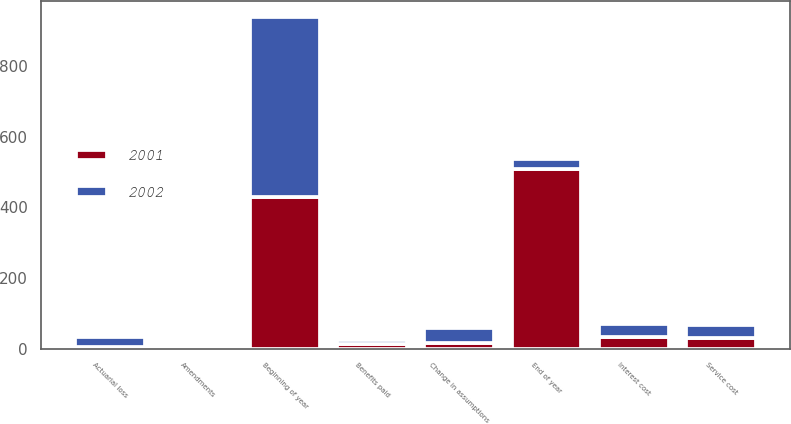Convert chart. <chart><loc_0><loc_0><loc_500><loc_500><stacked_bar_chart><ecel><fcel>Beginning of year<fcel>Service cost<fcel>Interest cost<fcel>Amendments<fcel>Change in assumptions<fcel>Actuarial loss<fcel>Benefits paid<fcel>End of year<nl><fcel>2001<fcel>430.2<fcel>29<fcel>32.3<fcel>5.2<fcel>16.4<fcel>6.2<fcel>12.1<fcel>507.2<nl><fcel>2002<fcel>507.2<fcel>37.2<fcel>38.6<fcel>3.8<fcel>41.3<fcel>25.7<fcel>13.1<fcel>29<nl></chart> 